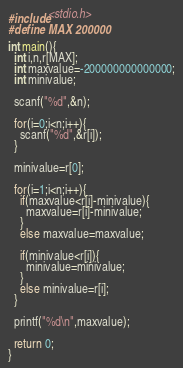Convert code to text. <code><loc_0><loc_0><loc_500><loc_500><_C_>#include<stdio.h>
#define MAX 200000

int main(){
  int i,n,r[MAX];
  int maxvalue=-200000000000000;
  int minivalue;

  scanf("%d",&n);

  for(i=0;i<n;i++){
    scanf("%d",&r[i]);
  }

  minivalue=r[0];

  for(i=1;i<n;i++){
    if(maxvalue<r[i]-minivalue){
      maxvalue=r[i]-minivalue;
    }
    else maxvalue=maxvalue;

    if(minivalue<r[i]){
      minivalue=minivalue;
    }
    else minivalue=r[i];
  }

  printf("%d\n",maxvalue);

  return 0;
}

</code> 